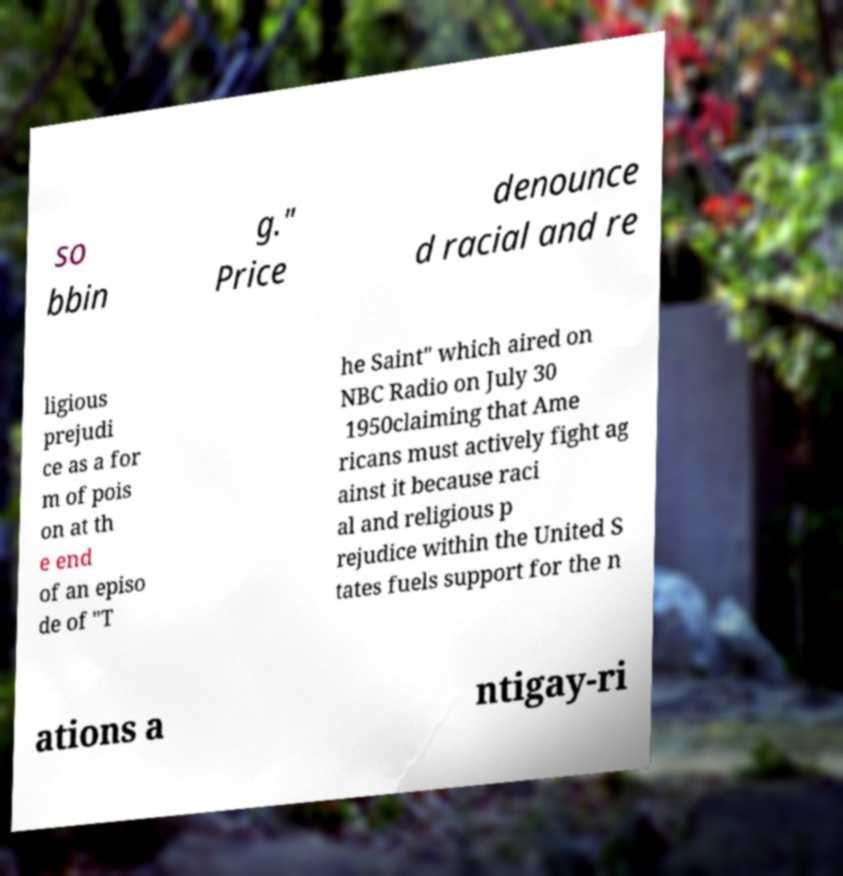Could you assist in decoding the text presented in this image and type it out clearly? so bbin g." Price denounce d racial and re ligious prejudi ce as a for m of pois on at th e end of an episo de of "T he Saint" which aired on NBC Radio on July 30 1950claiming that Ame ricans must actively fight ag ainst it because raci al and religious p rejudice within the United S tates fuels support for the n ations a ntigay-ri 